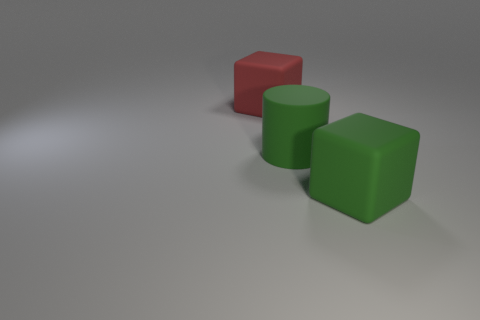There is a green object that is the same material as the big green cylinder; what is its size?
Offer a very short reply. Large. Is there anything else of the same color as the big rubber cylinder?
Offer a very short reply. Yes. There is a big rubber block that is on the left side of the large cylinder; what is its color?
Your answer should be compact. Red. Are there any large red rubber blocks to the right of the large block that is on the left side of the matte block that is to the right of the red cube?
Your response must be concise. No. Is the number of blocks that are behind the big red matte object greater than the number of large matte cylinders?
Ensure brevity in your answer.  No. There is a green object to the right of the big green matte cylinder; does it have the same shape as the big red matte object?
Provide a short and direct response. Yes. Is there any other thing that is the same material as the large green cube?
Ensure brevity in your answer.  Yes. What number of things are either large green cylinders or objects that are behind the large green block?
Your answer should be compact. 2. There is a matte thing that is in front of the large red matte cube and on the left side of the green block; what size is it?
Provide a succinct answer. Large. Is the number of green rubber blocks to the left of the large cylinder greater than the number of large green objects to the left of the large green block?
Make the answer very short. No. 